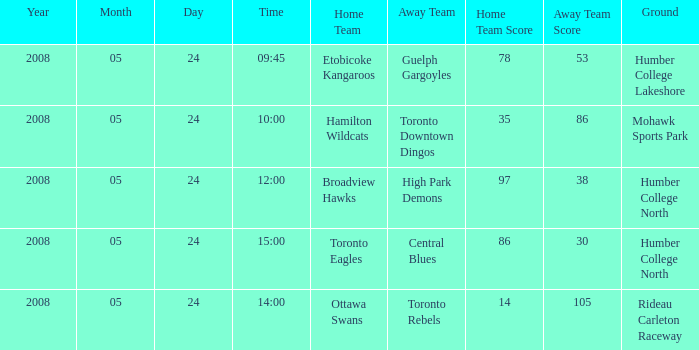Who was the away team of the game at the time 15:00? Central Blues. 